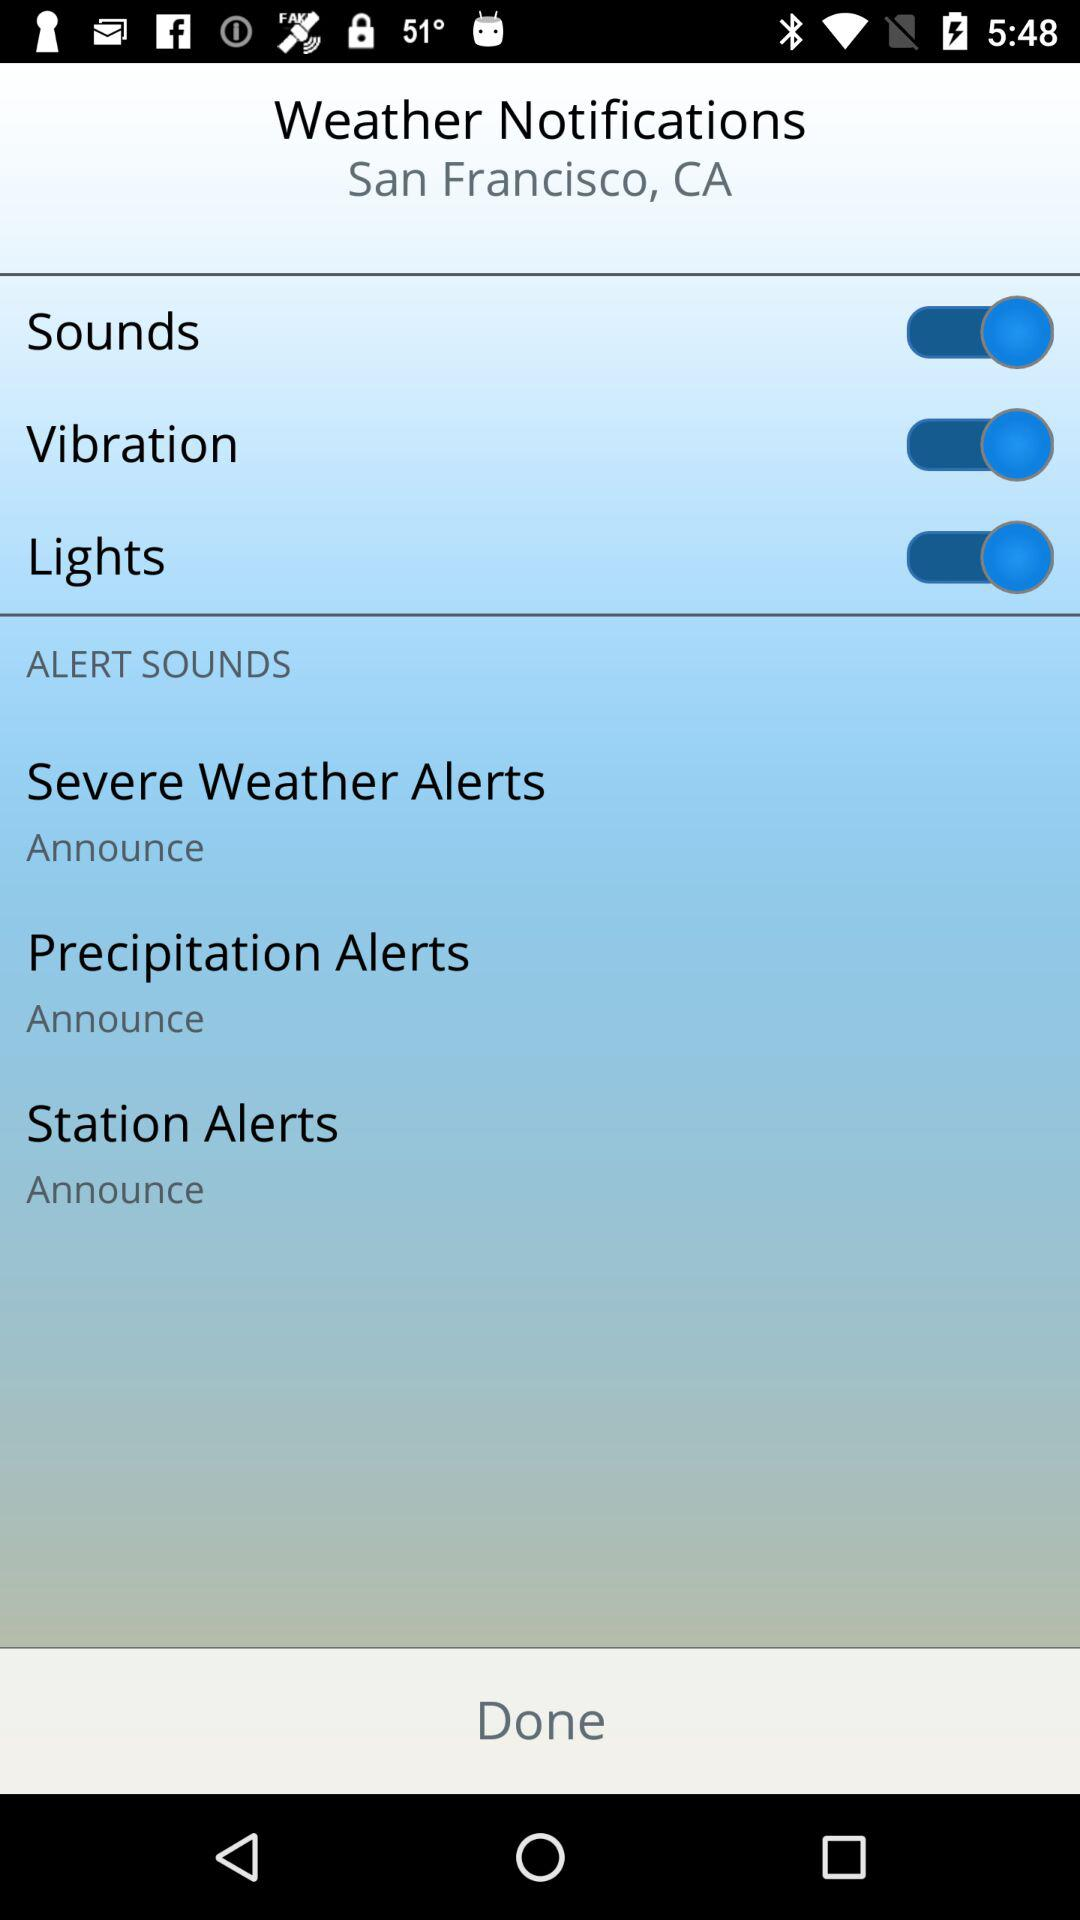Is "Station Alerts" checked or unchecked?
When the provided information is insufficient, respond with <no answer>. <no answer> 